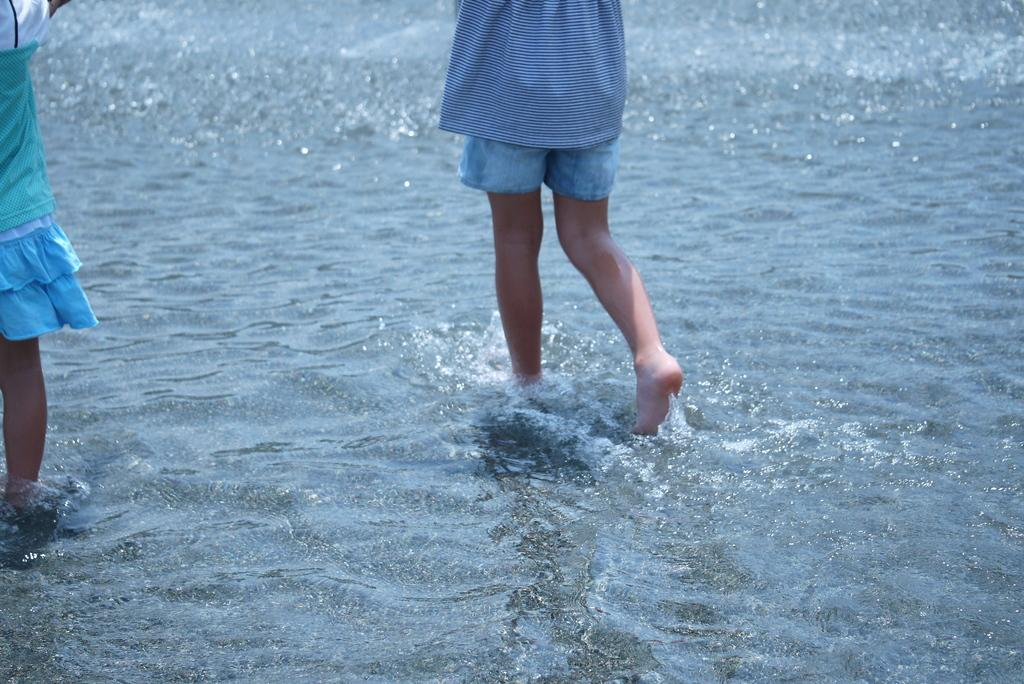What is happening with the child on the left side of the image? There is a child partially in the water on the left side of the image. What is the other child doing in the image? There is another child walking in the water on the right side of the image. What type of vase can be seen in the image? There is no vase present in the image; it features two children in the water. Is there a birthday celebration happening in the image? There is no indication of a birthday celebration in the image. 